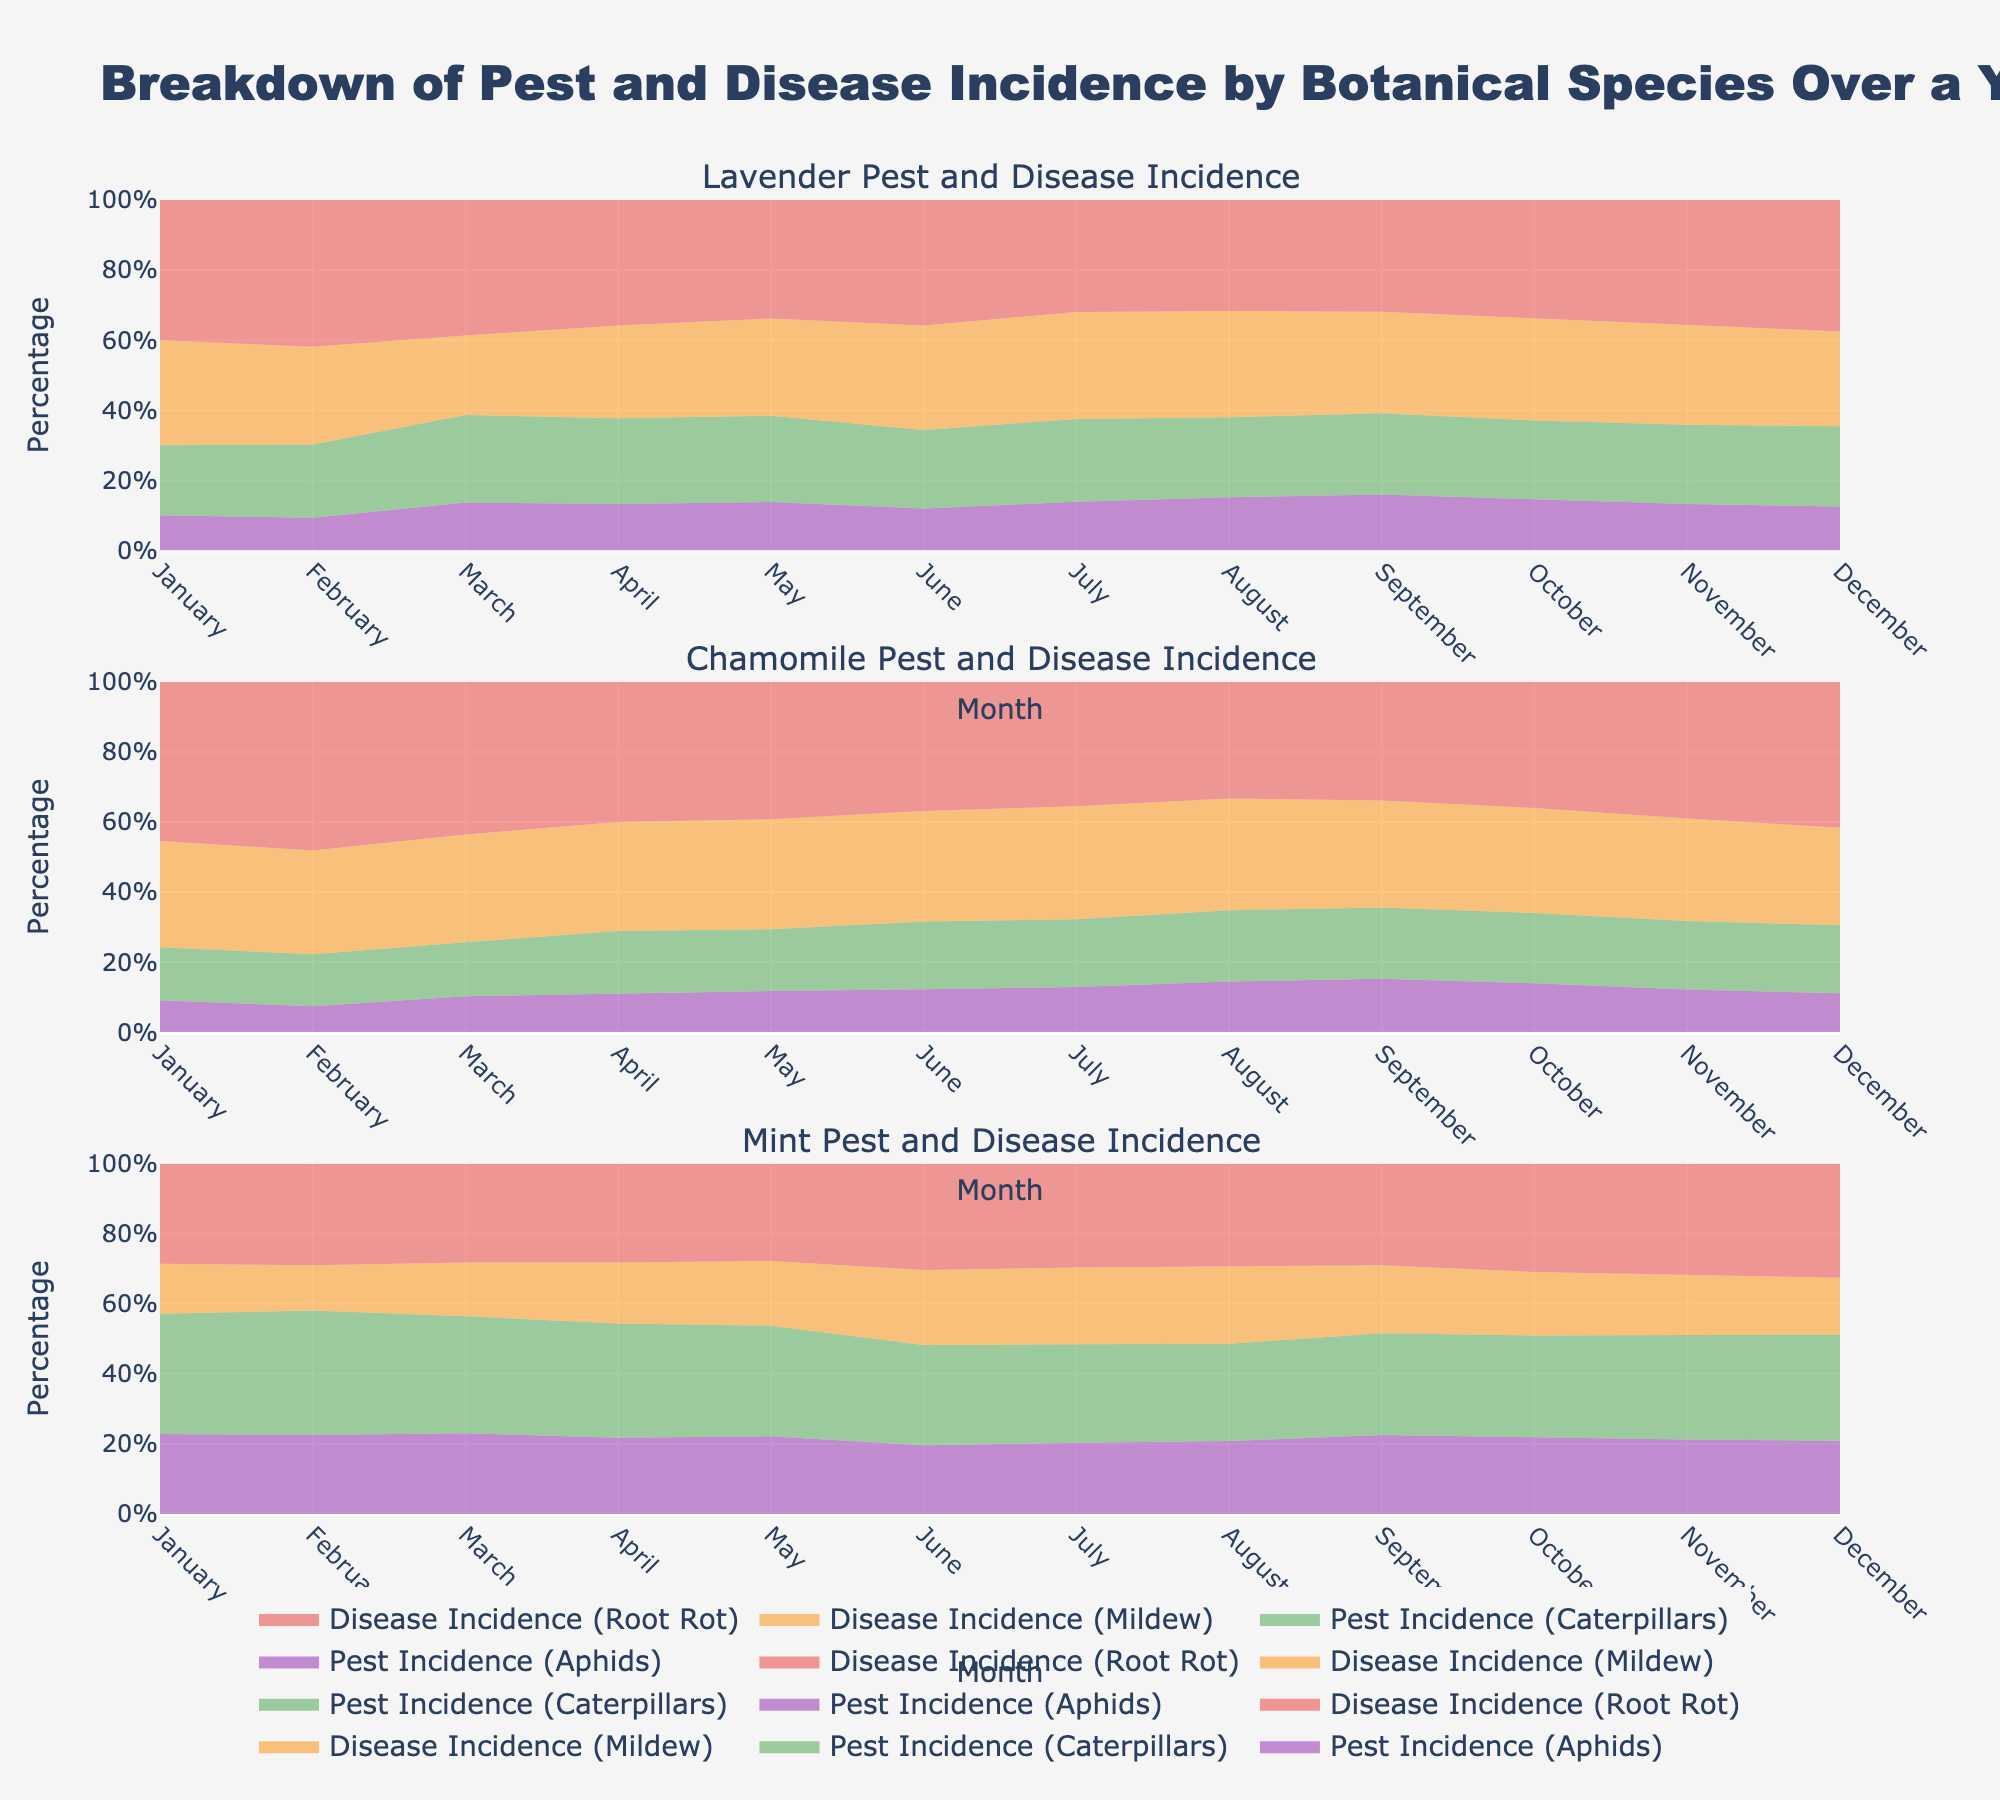What is the title of the chart? The title of the chart is usually located at the top of the figure. It provides a summary of what the chart represents. In this case, the title is "Breakdown of Pest and Disease Incidence by Botanical Species Over a Yearly Cycle".
Answer: Breakdown of Pest and Disease Incidence by Botanical Species Over a Yearly Cycle Which botanical species has the highest incidence of pests and diseases in July? To determine which species has the highest incidence, compare the stacked areas for all species in July. The species with the largest total stacked area represents the highest incidence.
Answer: Mint What is the trend for root rot incidence in Lavender throughout the year? To observe the trend, look at the layer representing root rot incidence in the Lavender subplot. Follow its height from January to December.
Answer: Increasing, then decreasing How do the incidence rates of aphids and caterpillars compare in Chamomile during August? Compare the heights of the areas for aphids and caterpillars in the Chamomile subplot in August. Notice which one is taller.
Answer: Caterpillars are higher In which month does Mint experience the lowest percentage of mildew incidence? To find the lowest mildew incidence, examine the mildew layer in the Mint subplot across all months and identify the month where it is smallest.
Answer: January What’s the average percentage of disease incidence (mildew and root rot) in Lavender during the summer months (June, July, August)? Calculate the sum of mildew and root rot incidences in June, July, and August for Lavender and find the average. (June: 20+24 = 44%, July: 22+23 = 45%, August: 24+25 = 49%; (44 + 45 + 49) / 3 = 46%)
Answer: 46% Does the chamomile species ever have a higher root rot incidence than mint in any month? Compare the root rot incidence layers between Chamomile and Mint for every month. Identify if there is any month where Chamomile’s root rot incidence is higher.
Answer: No Which pest has the most consistent incidence rate across all months for Lavender? To find the most consistent pest incidence, look at the total height stability of aphids and caterpillars across all months in the Lavender subplot.
Answer: Caterpillars During which month does the chamomile species have the largest total pest incidence (aphids + caterpillars)? Add the aphid and caterpillar incidence layers for each month in Chamomile and find the month with the highest total.
Answer: August Which month shows a noticeable spike in caterpillar incidence for mint? To identify a noticeable spike, observe the caterpillar incidence layer for Mint and find the month with a significant increase.
Answer: August 